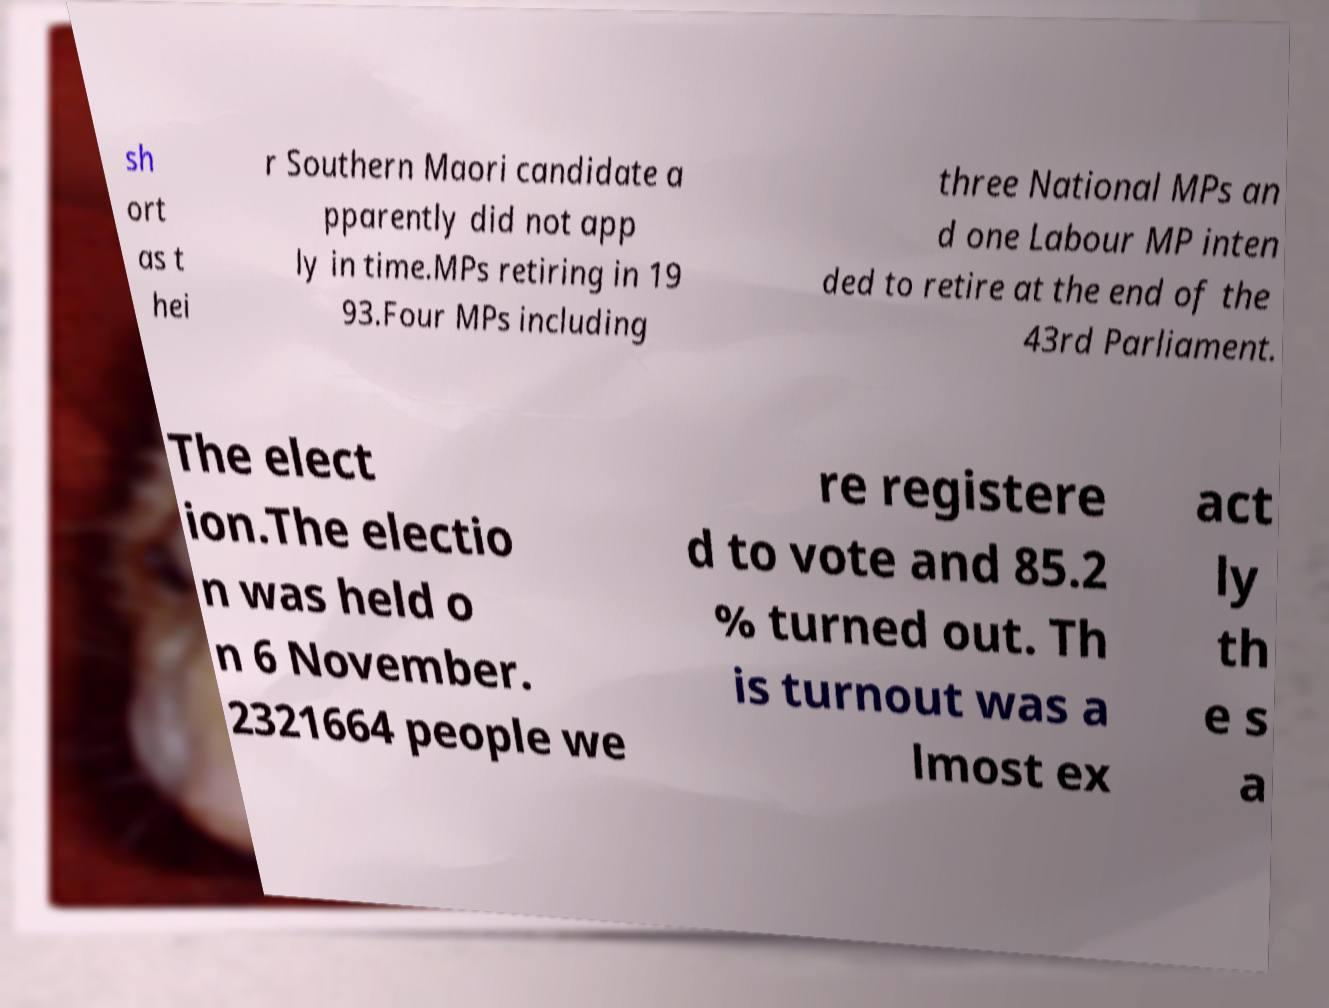Please read and relay the text visible in this image. What does it say? sh ort as t hei r Southern Maori candidate a pparently did not app ly in time.MPs retiring in 19 93.Four MPs including three National MPs an d one Labour MP inten ded to retire at the end of the 43rd Parliament. The elect ion.The electio n was held o n 6 November. 2321664 people we re registere d to vote and 85.2 % turned out. Th is turnout was a lmost ex act ly th e s a 